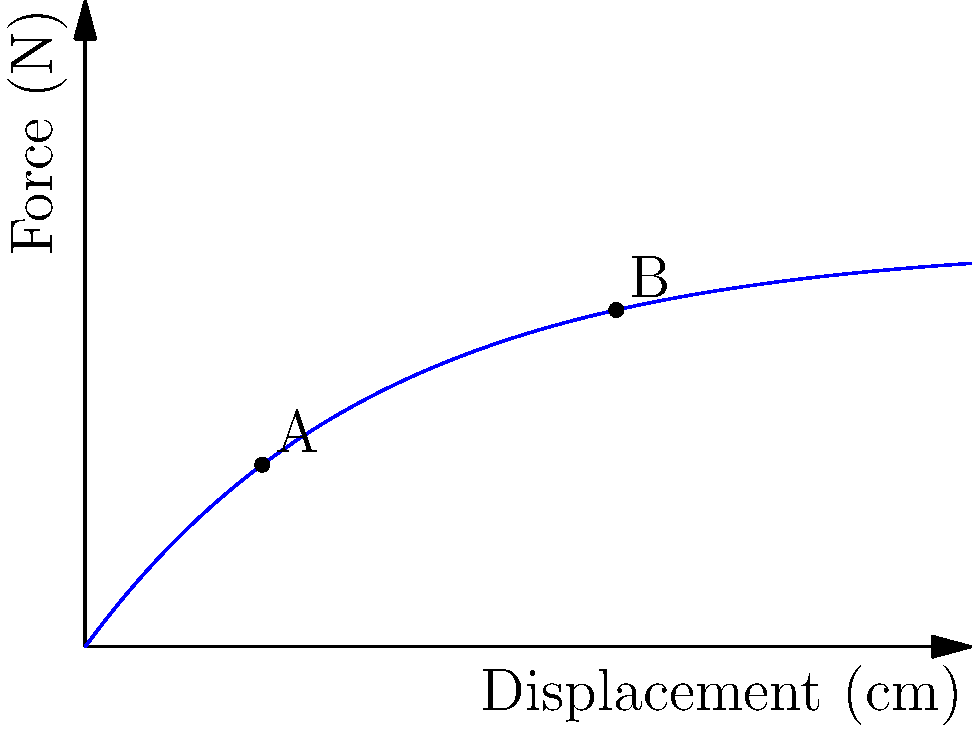In the force-displacement curve of a spring-mass system shown above, points A and B represent two different states of the system. If we consider the linguistic analogy of how Church Slavonic influenced modern Slavic languages, which of the following best describes the relationship between points A and B in terms of the system's energy state?

a) A represents a higher energy state, similar to how Church Slavonic preserved more archaic forms
b) B represents a higher energy state, analogous to how modern Slavic languages evolved from Church Slavonic
c) A and B have equal energy states, mirroring the equal status of Church Slavonic and modern Slavic languages
d) The energy states of A and B cannot be compared, just as the influence of Church Slavonic varies across different Slavic languages To answer this question, we need to analyze the force-displacement curve and understand the energy state of the spring-mass system:

1. In a spring-mass system, the potential energy is given by the area under the force-displacement curve.

2. The force-displacement curve shown is non-linear, indicating a non-linear spring or damping effect.

3. Point A is at a displacement of approximately 2 cm, while point B is at a displacement of approximately 6 cm.

4. To compare the energy states, we need to calculate the area under the curve up to each point:
   
   $E = \int_0^x F(x) dx$

   where $F(x)$ is the force function and $x$ is the displacement.

5. Visually, we can see that the area under the curve up to point B is significantly larger than the area up to point A.

6. This means that the system at point B has more potential energy stored than at point A.

7. In the context of the linguistic analogy, this is similar to how modern Slavic languages (represented by point B) have evolved and developed more complex structures and vocabulary over time, building upon the foundation of Church Slavonic (which could be represented by point A).

Therefore, the correct answer is b) B represents a higher energy state, analogous to how modern Slavic languages evolved from Church Slavonic.
Answer: b) B represents a higher energy state, analogous to how modern Slavic languages evolved from Church Slavonic 